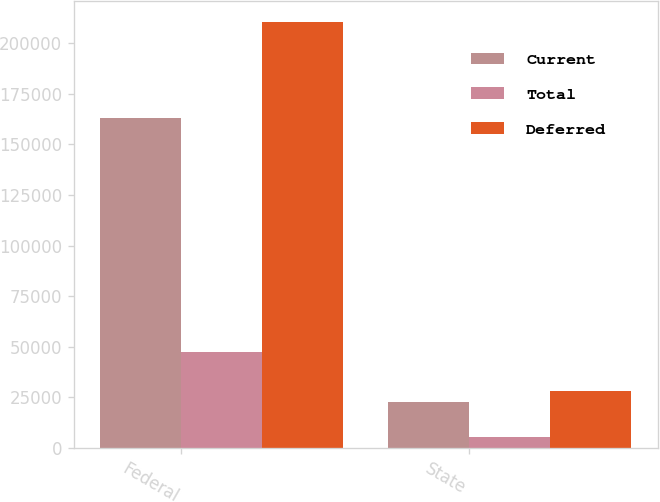Convert chart to OTSL. <chart><loc_0><loc_0><loc_500><loc_500><stacked_bar_chart><ecel><fcel>Federal<fcel>State<nl><fcel>Current<fcel>162891<fcel>22626<nl><fcel>Total<fcel>47436<fcel>5601<nl><fcel>Deferred<fcel>210327<fcel>28227<nl></chart> 